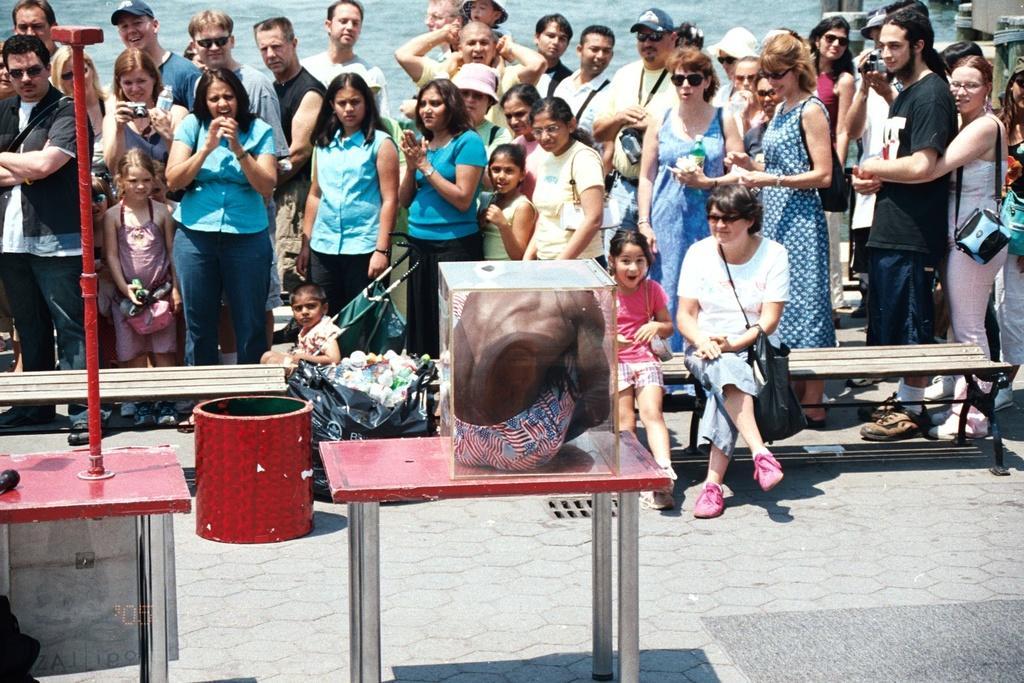Can you describe this image briefly? In this image at front there are two tables. On one of the table there is a person sitting inside the glass box. In front of the table there is a dustbin. Beside the dustbin two people are sitting on the bench. At the backside people are standing on the floor. At the background there is water. 